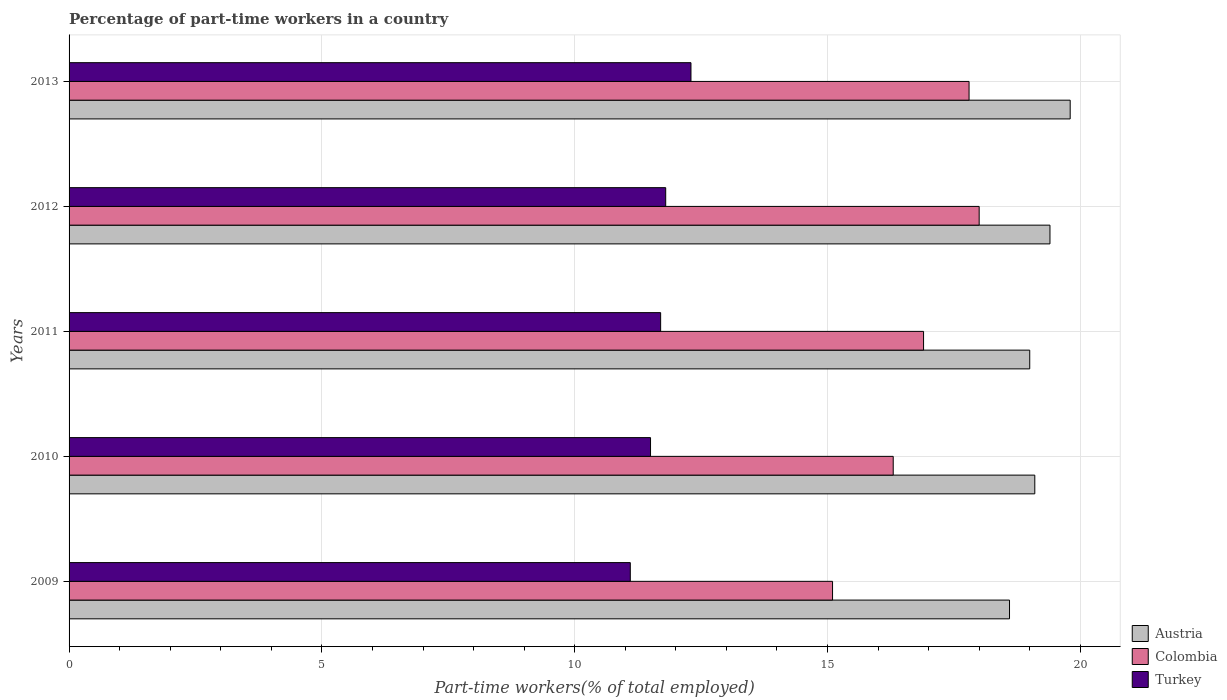How many groups of bars are there?
Make the answer very short. 5. Are the number of bars per tick equal to the number of legend labels?
Give a very brief answer. Yes. Are the number of bars on each tick of the Y-axis equal?
Your answer should be compact. Yes. How many bars are there on the 5th tick from the top?
Ensure brevity in your answer.  3. What is the percentage of part-time workers in Turkey in 2011?
Ensure brevity in your answer.  11.7. Across all years, what is the maximum percentage of part-time workers in Turkey?
Ensure brevity in your answer.  12.3. Across all years, what is the minimum percentage of part-time workers in Turkey?
Give a very brief answer. 11.1. In which year was the percentage of part-time workers in Austria maximum?
Offer a very short reply. 2013. What is the total percentage of part-time workers in Turkey in the graph?
Offer a terse response. 58.4. What is the difference between the percentage of part-time workers in Turkey in 2011 and that in 2012?
Offer a terse response. -0.1. What is the difference between the percentage of part-time workers in Turkey in 2010 and the percentage of part-time workers in Austria in 2011?
Make the answer very short. -7.5. What is the average percentage of part-time workers in Colombia per year?
Give a very brief answer. 16.82. In the year 2009, what is the difference between the percentage of part-time workers in Turkey and percentage of part-time workers in Colombia?
Provide a succinct answer. -4. What is the ratio of the percentage of part-time workers in Colombia in 2010 to that in 2013?
Your response must be concise. 0.92. What is the difference between the highest and the second highest percentage of part-time workers in Colombia?
Give a very brief answer. 0.2. What is the difference between the highest and the lowest percentage of part-time workers in Colombia?
Make the answer very short. 2.9. In how many years, is the percentage of part-time workers in Colombia greater than the average percentage of part-time workers in Colombia taken over all years?
Your response must be concise. 3. Is the sum of the percentage of part-time workers in Colombia in 2009 and 2010 greater than the maximum percentage of part-time workers in Austria across all years?
Make the answer very short. Yes. What does the 2nd bar from the bottom in 2013 represents?
Offer a very short reply. Colombia. Is it the case that in every year, the sum of the percentage of part-time workers in Turkey and percentage of part-time workers in Colombia is greater than the percentage of part-time workers in Austria?
Offer a very short reply. Yes. How many bars are there?
Your answer should be compact. 15. Are all the bars in the graph horizontal?
Provide a short and direct response. Yes. How many years are there in the graph?
Ensure brevity in your answer.  5. What is the difference between two consecutive major ticks on the X-axis?
Ensure brevity in your answer.  5. Are the values on the major ticks of X-axis written in scientific E-notation?
Provide a succinct answer. No. Does the graph contain any zero values?
Your response must be concise. No. Where does the legend appear in the graph?
Provide a succinct answer. Bottom right. How many legend labels are there?
Offer a very short reply. 3. What is the title of the graph?
Your response must be concise. Percentage of part-time workers in a country. Does "Belarus" appear as one of the legend labels in the graph?
Make the answer very short. No. What is the label or title of the X-axis?
Keep it short and to the point. Part-time workers(% of total employed). What is the Part-time workers(% of total employed) of Austria in 2009?
Ensure brevity in your answer.  18.6. What is the Part-time workers(% of total employed) in Colombia in 2009?
Your response must be concise. 15.1. What is the Part-time workers(% of total employed) of Turkey in 2009?
Ensure brevity in your answer.  11.1. What is the Part-time workers(% of total employed) in Austria in 2010?
Provide a short and direct response. 19.1. What is the Part-time workers(% of total employed) of Colombia in 2010?
Your response must be concise. 16.3. What is the Part-time workers(% of total employed) in Austria in 2011?
Provide a short and direct response. 19. What is the Part-time workers(% of total employed) in Colombia in 2011?
Provide a short and direct response. 16.9. What is the Part-time workers(% of total employed) of Turkey in 2011?
Ensure brevity in your answer.  11.7. What is the Part-time workers(% of total employed) in Austria in 2012?
Keep it short and to the point. 19.4. What is the Part-time workers(% of total employed) in Colombia in 2012?
Your answer should be very brief. 18. What is the Part-time workers(% of total employed) of Turkey in 2012?
Your answer should be compact. 11.8. What is the Part-time workers(% of total employed) of Austria in 2013?
Your response must be concise. 19.8. What is the Part-time workers(% of total employed) of Colombia in 2013?
Provide a succinct answer. 17.8. What is the Part-time workers(% of total employed) of Turkey in 2013?
Make the answer very short. 12.3. Across all years, what is the maximum Part-time workers(% of total employed) in Austria?
Your answer should be very brief. 19.8. Across all years, what is the maximum Part-time workers(% of total employed) of Colombia?
Offer a terse response. 18. Across all years, what is the maximum Part-time workers(% of total employed) of Turkey?
Provide a short and direct response. 12.3. Across all years, what is the minimum Part-time workers(% of total employed) of Austria?
Your answer should be very brief. 18.6. Across all years, what is the minimum Part-time workers(% of total employed) in Colombia?
Keep it short and to the point. 15.1. Across all years, what is the minimum Part-time workers(% of total employed) of Turkey?
Ensure brevity in your answer.  11.1. What is the total Part-time workers(% of total employed) in Austria in the graph?
Offer a very short reply. 95.9. What is the total Part-time workers(% of total employed) in Colombia in the graph?
Your answer should be very brief. 84.1. What is the total Part-time workers(% of total employed) of Turkey in the graph?
Give a very brief answer. 58.4. What is the difference between the Part-time workers(% of total employed) of Turkey in 2009 and that in 2010?
Provide a succinct answer. -0.4. What is the difference between the Part-time workers(% of total employed) in Austria in 2009 and that in 2011?
Ensure brevity in your answer.  -0.4. What is the difference between the Part-time workers(% of total employed) of Turkey in 2009 and that in 2011?
Offer a terse response. -0.6. What is the difference between the Part-time workers(% of total employed) in Colombia in 2009 and that in 2012?
Offer a very short reply. -2.9. What is the difference between the Part-time workers(% of total employed) in Austria in 2009 and that in 2013?
Your answer should be compact. -1.2. What is the difference between the Part-time workers(% of total employed) in Colombia in 2009 and that in 2013?
Your response must be concise. -2.7. What is the difference between the Part-time workers(% of total employed) of Turkey in 2009 and that in 2013?
Ensure brevity in your answer.  -1.2. What is the difference between the Part-time workers(% of total employed) in Austria in 2010 and that in 2011?
Offer a terse response. 0.1. What is the difference between the Part-time workers(% of total employed) of Colombia in 2010 and that in 2011?
Keep it short and to the point. -0.6. What is the difference between the Part-time workers(% of total employed) in Turkey in 2010 and that in 2011?
Offer a very short reply. -0.2. What is the difference between the Part-time workers(% of total employed) in Turkey in 2010 and that in 2012?
Provide a short and direct response. -0.3. What is the difference between the Part-time workers(% of total employed) in Austria in 2010 and that in 2013?
Your answer should be very brief. -0.7. What is the difference between the Part-time workers(% of total employed) in Colombia in 2010 and that in 2013?
Ensure brevity in your answer.  -1.5. What is the difference between the Part-time workers(% of total employed) in Austria in 2011 and that in 2012?
Provide a succinct answer. -0.4. What is the difference between the Part-time workers(% of total employed) of Colombia in 2011 and that in 2012?
Offer a very short reply. -1.1. What is the difference between the Part-time workers(% of total employed) of Turkey in 2011 and that in 2012?
Your answer should be very brief. -0.1. What is the difference between the Part-time workers(% of total employed) of Colombia in 2011 and that in 2013?
Make the answer very short. -0.9. What is the difference between the Part-time workers(% of total employed) in Turkey in 2011 and that in 2013?
Offer a very short reply. -0.6. What is the difference between the Part-time workers(% of total employed) in Austria in 2012 and that in 2013?
Provide a succinct answer. -0.4. What is the difference between the Part-time workers(% of total employed) of Turkey in 2012 and that in 2013?
Your answer should be very brief. -0.5. What is the difference between the Part-time workers(% of total employed) in Colombia in 2009 and the Part-time workers(% of total employed) in Turkey in 2010?
Ensure brevity in your answer.  3.6. What is the difference between the Part-time workers(% of total employed) of Austria in 2009 and the Part-time workers(% of total employed) of Colombia in 2011?
Give a very brief answer. 1.7. What is the difference between the Part-time workers(% of total employed) in Austria in 2009 and the Part-time workers(% of total employed) in Turkey in 2011?
Keep it short and to the point. 6.9. What is the difference between the Part-time workers(% of total employed) in Colombia in 2009 and the Part-time workers(% of total employed) in Turkey in 2011?
Your response must be concise. 3.4. What is the difference between the Part-time workers(% of total employed) of Colombia in 2009 and the Part-time workers(% of total employed) of Turkey in 2012?
Ensure brevity in your answer.  3.3. What is the difference between the Part-time workers(% of total employed) in Austria in 2009 and the Part-time workers(% of total employed) in Colombia in 2013?
Keep it short and to the point. 0.8. What is the difference between the Part-time workers(% of total employed) in Austria in 2009 and the Part-time workers(% of total employed) in Turkey in 2013?
Offer a terse response. 6.3. What is the difference between the Part-time workers(% of total employed) in Austria in 2010 and the Part-time workers(% of total employed) in Colombia in 2011?
Keep it short and to the point. 2.2. What is the difference between the Part-time workers(% of total employed) in Austria in 2010 and the Part-time workers(% of total employed) in Turkey in 2012?
Your answer should be very brief. 7.3. What is the difference between the Part-time workers(% of total employed) of Austria in 2011 and the Part-time workers(% of total employed) of Colombia in 2012?
Offer a very short reply. 1. What is the difference between the Part-time workers(% of total employed) in Austria in 2011 and the Part-time workers(% of total employed) in Turkey in 2013?
Ensure brevity in your answer.  6.7. What is the difference between the Part-time workers(% of total employed) of Austria in 2012 and the Part-time workers(% of total employed) of Turkey in 2013?
Give a very brief answer. 7.1. What is the difference between the Part-time workers(% of total employed) of Colombia in 2012 and the Part-time workers(% of total employed) of Turkey in 2013?
Provide a succinct answer. 5.7. What is the average Part-time workers(% of total employed) of Austria per year?
Provide a succinct answer. 19.18. What is the average Part-time workers(% of total employed) of Colombia per year?
Your answer should be compact. 16.82. What is the average Part-time workers(% of total employed) of Turkey per year?
Offer a very short reply. 11.68. In the year 2009, what is the difference between the Part-time workers(% of total employed) in Austria and Part-time workers(% of total employed) in Colombia?
Provide a short and direct response. 3.5. In the year 2009, what is the difference between the Part-time workers(% of total employed) of Austria and Part-time workers(% of total employed) of Turkey?
Keep it short and to the point. 7.5. In the year 2010, what is the difference between the Part-time workers(% of total employed) in Austria and Part-time workers(% of total employed) in Colombia?
Give a very brief answer. 2.8. In the year 2010, what is the difference between the Part-time workers(% of total employed) in Austria and Part-time workers(% of total employed) in Turkey?
Make the answer very short. 7.6. In the year 2011, what is the difference between the Part-time workers(% of total employed) in Austria and Part-time workers(% of total employed) in Turkey?
Give a very brief answer. 7.3. In the year 2012, what is the difference between the Part-time workers(% of total employed) in Austria and Part-time workers(% of total employed) in Turkey?
Your response must be concise. 7.6. In the year 2012, what is the difference between the Part-time workers(% of total employed) of Colombia and Part-time workers(% of total employed) of Turkey?
Give a very brief answer. 6.2. In the year 2013, what is the difference between the Part-time workers(% of total employed) of Austria and Part-time workers(% of total employed) of Turkey?
Your answer should be very brief. 7.5. What is the ratio of the Part-time workers(% of total employed) of Austria in 2009 to that in 2010?
Provide a succinct answer. 0.97. What is the ratio of the Part-time workers(% of total employed) of Colombia in 2009 to that in 2010?
Provide a short and direct response. 0.93. What is the ratio of the Part-time workers(% of total employed) in Turkey in 2009 to that in 2010?
Your response must be concise. 0.97. What is the ratio of the Part-time workers(% of total employed) of Austria in 2009 to that in 2011?
Offer a terse response. 0.98. What is the ratio of the Part-time workers(% of total employed) in Colombia in 2009 to that in 2011?
Make the answer very short. 0.89. What is the ratio of the Part-time workers(% of total employed) in Turkey in 2009 to that in 2011?
Provide a short and direct response. 0.95. What is the ratio of the Part-time workers(% of total employed) in Austria in 2009 to that in 2012?
Your response must be concise. 0.96. What is the ratio of the Part-time workers(% of total employed) of Colombia in 2009 to that in 2012?
Give a very brief answer. 0.84. What is the ratio of the Part-time workers(% of total employed) of Turkey in 2009 to that in 2012?
Your answer should be compact. 0.94. What is the ratio of the Part-time workers(% of total employed) in Austria in 2009 to that in 2013?
Your response must be concise. 0.94. What is the ratio of the Part-time workers(% of total employed) of Colombia in 2009 to that in 2013?
Your response must be concise. 0.85. What is the ratio of the Part-time workers(% of total employed) in Turkey in 2009 to that in 2013?
Ensure brevity in your answer.  0.9. What is the ratio of the Part-time workers(% of total employed) of Colombia in 2010 to that in 2011?
Your answer should be very brief. 0.96. What is the ratio of the Part-time workers(% of total employed) in Turkey in 2010 to that in 2011?
Give a very brief answer. 0.98. What is the ratio of the Part-time workers(% of total employed) of Austria in 2010 to that in 2012?
Provide a short and direct response. 0.98. What is the ratio of the Part-time workers(% of total employed) in Colombia in 2010 to that in 2012?
Keep it short and to the point. 0.91. What is the ratio of the Part-time workers(% of total employed) in Turkey in 2010 to that in 2012?
Provide a succinct answer. 0.97. What is the ratio of the Part-time workers(% of total employed) of Austria in 2010 to that in 2013?
Provide a succinct answer. 0.96. What is the ratio of the Part-time workers(% of total employed) of Colombia in 2010 to that in 2013?
Make the answer very short. 0.92. What is the ratio of the Part-time workers(% of total employed) of Turkey in 2010 to that in 2013?
Give a very brief answer. 0.94. What is the ratio of the Part-time workers(% of total employed) in Austria in 2011 to that in 2012?
Give a very brief answer. 0.98. What is the ratio of the Part-time workers(% of total employed) in Colombia in 2011 to that in 2012?
Offer a terse response. 0.94. What is the ratio of the Part-time workers(% of total employed) of Austria in 2011 to that in 2013?
Your answer should be very brief. 0.96. What is the ratio of the Part-time workers(% of total employed) in Colombia in 2011 to that in 2013?
Provide a succinct answer. 0.95. What is the ratio of the Part-time workers(% of total employed) in Turkey in 2011 to that in 2013?
Keep it short and to the point. 0.95. What is the ratio of the Part-time workers(% of total employed) of Austria in 2012 to that in 2013?
Provide a succinct answer. 0.98. What is the ratio of the Part-time workers(% of total employed) of Colombia in 2012 to that in 2013?
Ensure brevity in your answer.  1.01. What is the ratio of the Part-time workers(% of total employed) in Turkey in 2012 to that in 2013?
Ensure brevity in your answer.  0.96. What is the difference between the highest and the second highest Part-time workers(% of total employed) in Austria?
Ensure brevity in your answer.  0.4. What is the difference between the highest and the second highest Part-time workers(% of total employed) of Colombia?
Offer a terse response. 0.2. What is the difference between the highest and the second highest Part-time workers(% of total employed) in Turkey?
Make the answer very short. 0.5. What is the difference between the highest and the lowest Part-time workers(% of total employed) in Austria?
Offer a terse response. 1.2. What is the difference between the highest and the lowest Part-time workers(% of total employed) of Colombia?
Provide a succinct answer. 2.9. What is the difference between the highest and the lowest Part-time workers(% of total employed) in Turkey?
Offer a very short reply. 1.2. 